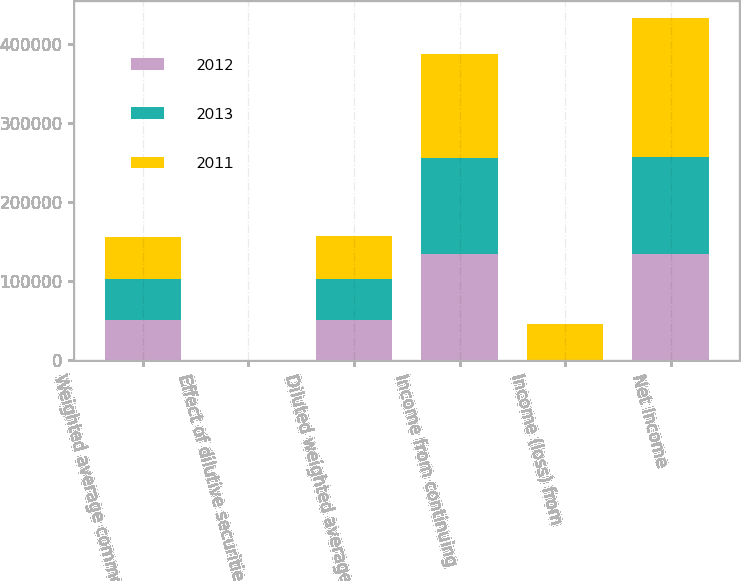Convert chart to OTSL. <chart><loc_0><loc_0><loc_500><loc_500><stacked_bar_chart><ecel><fcel>Weighted average common shares<fcel>Effect of dilutive securities<fcel>Diluted weighted average<fcel>Income from continuing<fcel>Income (loss) from<fcel>Net Income<nl><fcel>2012<fcel>50693<fcel>370<fcel>51063<fcel>134225<fcel>133<fcel>134358<nl><fcel>2013<fcel>51566<fcel>277<fcel>51843<fcel>121897<fcel>1007<fcel>122904<nl><fcel>2011<fcel>53854<fcel>337<fcel>54191<fcel>130343<fcel>44300<fcel>174643<nl></chart> 